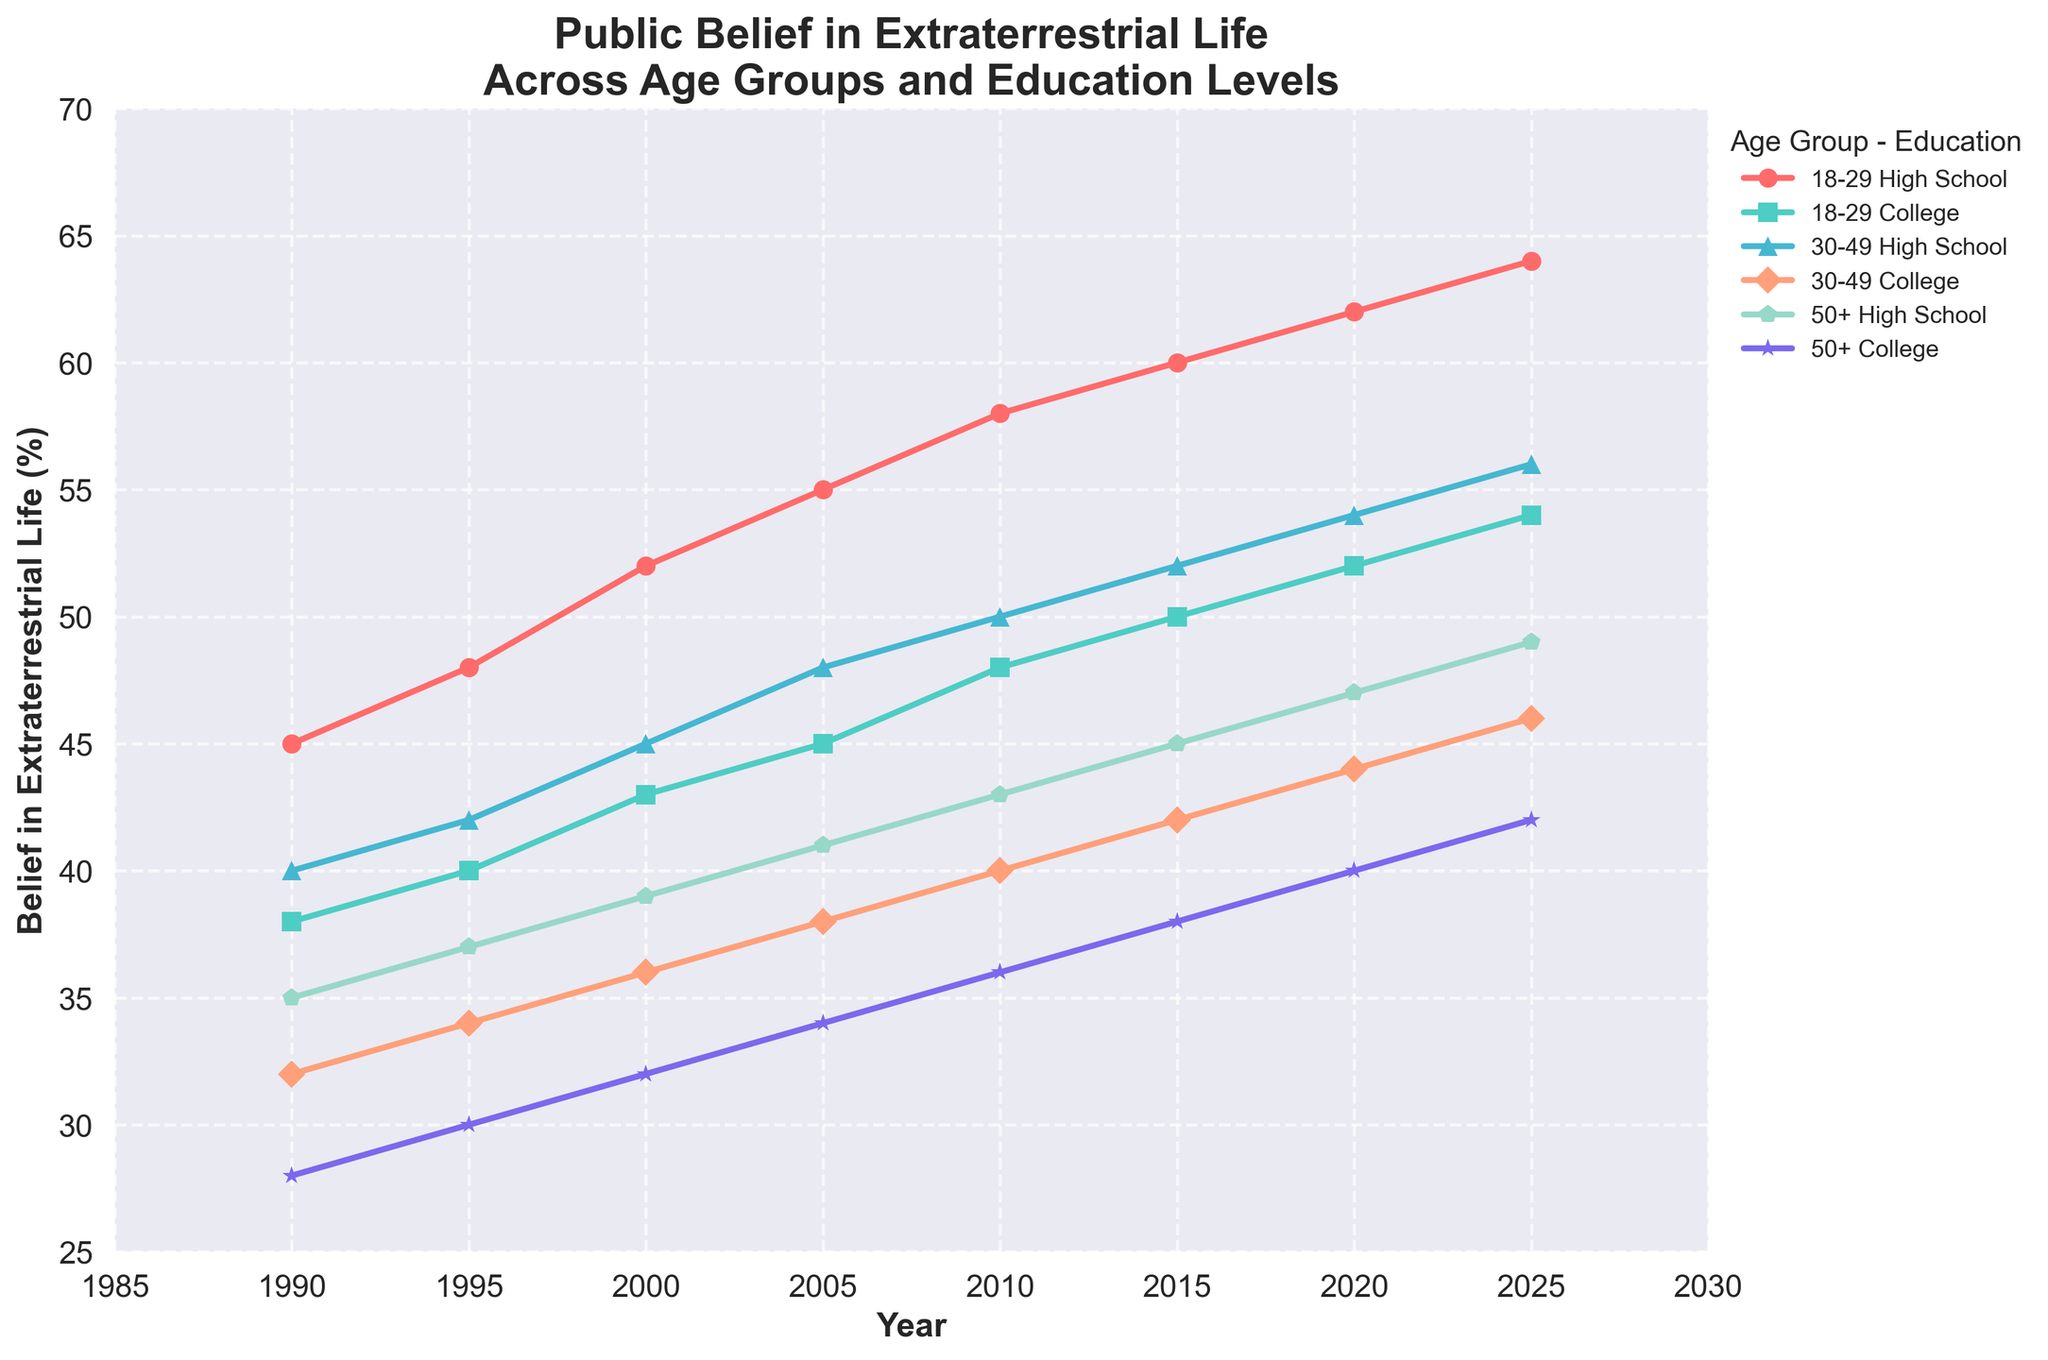What general trend can be observed in public belief in extraterrestrial life across all groups from 1990 to 2025? The belief in extraterrestrial life shows an increasing trend across all age groups and education levels from 1990 to 2025. By observing the line chart, all lines slope upwards over the time period, indicating a growing belief over time.
Answer: Belief is increasing Among the 18-29 age group, how do the beliefs of people with a high school education compare to those with a college education in the year 1990? In 1990, the line for 18-29 High School is higher than the line for 18-29 College. The exact values are 45% for high school and 38% for college-educated individuals, indicating that belief in extraterrestrial life is higher among high school graduates than college graduates in this age group.
Answer: Higher for high school What is the percentage increase in belief in extraterrestrial life for the 50+ High School group from 1990 to 2025? In 1990, the belief for 50+ High School is 35%. In 2025, it’s 49%. The percentage increase can be calculated as ((49 - 35)/35) * 100%, which equals approximately 40%.
Answer: 40% Which age group with a college education saw the highest increase in belief from 1990 to 2025? Observing the lines for college-educated groups, the belief for 18-29 College increased from 38% in 1990 to 54% in 2025. For 30-49 College, it increased from 32% to 46%. For 50+ College, it increased from 28% to 42%. The increase for 18-29 College (54% - 38% = 16%) is the highest.
Answer: 18-29 Did any age group show a belief of 50% or more as early as 2000? By closely examining the lines and their values for the year 2000, only the 18-29 High School group shows a belief of 52%, which is above 50%. No other groups reach 50% or more at this time.
Answer: Yes, 18-29 High School Which group has the lowest belief in extraterrestrial life in 2010? Checking the line values for 2010, the 50+ College group shows a belief of 36%, which is the lowest among all groups in that year.
Answer: 50+ College Compare the beliefs of 30-49-year-olds with a high school education and a college education in the year 2020. In 2020, the belief percentage for 30-49 High School is 54%, while for 30-49 College it is 44%. This shows that those with a high school education have a higher belief in extraterrestrial life at this point in time.
Answer: Higher for high school What is the average belief percentage of the 30-49 College group over the decades 1990, 2000, 2010, and 2020? The values for 30-49 College in 1990, 2000, 2010, and 2020 are 32%, 36%, 40%, and 44% respectively. The average can be calculated as (32 + 36 + 40 + 44)/4 = 38%.
Answer: 38% How does the belief of 50+ High School graduates in 2025 compare to the belief of 18-29 College graduates in 2005? The belief for 50+ High School graduates in 2025 is 49%. For 18-29 College graduates in 2005, it is 45%. Therefore, the belief for 50+ High School graduates in 2025 is higher.
Answer: Higher Among the lines representing different groups, which has the steepest increase in belief from 2005 to 2025? Observing the slope of the lines between 2005 and 2025, the 18-29 High School group shows a steep increase from 55% to 64%, which is an increase of 9%. This appears to be the steepest increase compared to other groups.
Answer: 18-29 High School 